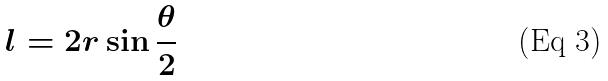Convert formula to latex. <formula><loc_0><loc_0><loc_500><loc_500>l = 2 r \sin \frac { \theta } { 2 }</formula> 